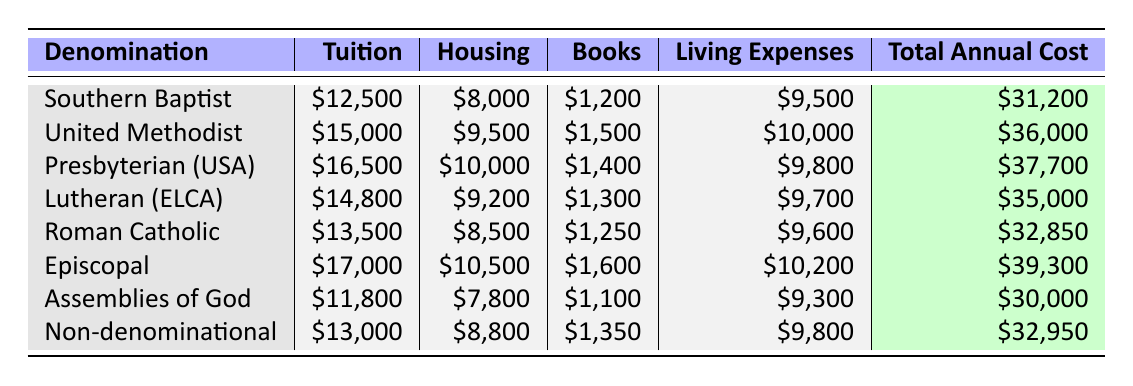What is the total annual cost for a Southern Baptist seminary student? From the table, the total annual cost for a Southern Baptist is listed as $31,200.
Answer: $31,200 Which denomination has the highest total annual cost? Upon reviewing the table, the Episcopal denomination has the highest total annual cost at $39,300.
Answer: Episcopal What is the average tuition cost across all listed denominations? Adding the tuition costs: $12,500 + $15,000 + $16,500 + $14,800 + $13,500 + $17,000 + $11,800 + $13,000 = $119,100. There are 8 denominations, so the average tuition cost is $119,100/8 = $14,887.50.
Answer: $14,887.50 Is the total annual cost for the Assemblies of God less than that for the Lutheran (ELCA)? The total annual cost for Assemblies of God is $30,000, while for Lutheran (ELCA) it is $35,000. Since $30,000 is less than $35,000, the statement is true.
Answer: Yes What is the difference in total annual cost between the United Methodist and Anglican denominations? The total annual cost for United Methodist is $36,000 and for Episcopal is $39,300. The difference is $39,300 - $36,000 = $3,300.
Answer: $3,300 What denomination has the lowest living expenses? From the table, the Assemblies of God denomination has the lowest living expenses at $9,300.
Answer: Assemblies of God How do the total annual costs of denominational students compare overall? The total annual costs for each denomination are different, with Episcopal being the highest and Assemblies of God being the lowest. The range in costs is calculated as $39,300 (Episcopal) - $30,000 (Assemblies of God) = $9,300.
Answer: The costs range from $30,000 to $39,300, a difference of $9,300 What is the median cost of books across all denominations? Listing the book costs: $1,200, $1,500, $1,400, $1,300, $1,250, $1,600, $1,100, $1,350. Arranging them in order: $1,100, $1,200, $1,250, $1,300, $1,350, $1,400, $1,500, $1,600, the median is the average of the 4th and 5th values, which is ($1,300 + $1,350) / 2 = $1,325.
Answer: $1,325 